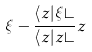Convert formula to latex. <formula><loc_0><loc_0><loc_500><loc_500>\xi - \frac { \langle z | \xi \rangle } { \langle z | z \rangle } z</formula> 